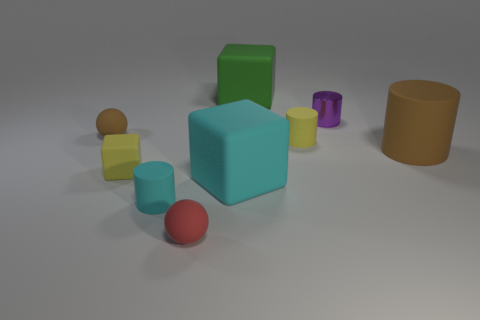Subtract 0 blue spheres. How many objects are left? 9 Subtract all blocks. How many objects are left? 6 Subtract 2 balls. How many balls are left? 0 Subtract all gray cylinders. Subtract all yellow cubes. How many cylinders are left? 4 Subtract all red spheres. How many cyan cylinders are left? 1 Subtract all cyan cubes. Subtract all small matte cylinders. How many objects are left? 6 Add 6 small cyan cylinders. How many small cyan cylinders are left? 7 Add 2 large cyan rubber blocks. How many large cyan rubber blocks exist? 3 Add 1 tiny yellow objects. How many objects exist? 10 Subtract all yellow cylinders. How many cylinders are left? 3 